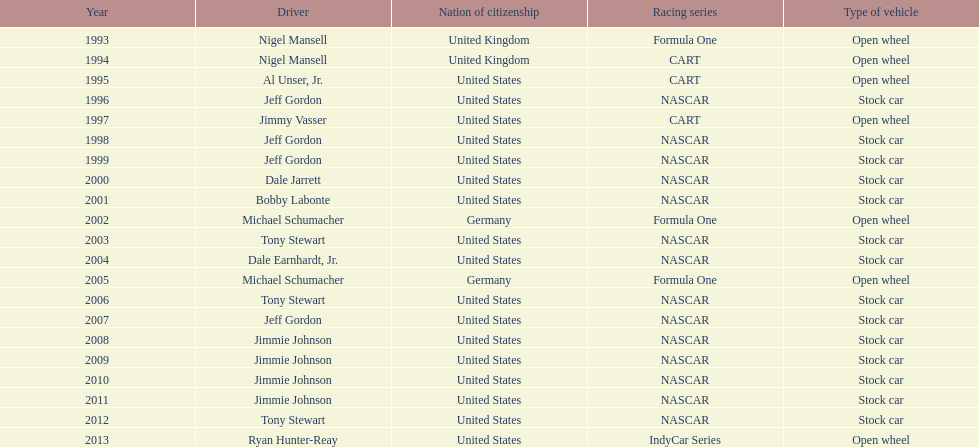Which drivers have won the best driver espy award? Nigel Mansell, Nigel Mansell, Al Unser, Jr., Jeff Gordon, Jimmy Vasser, Jeff Gordon, Jeff Gordon, Dale Jarrett, Bobby Labonte, Michael Schumacher, Tony Stewart, Dale Earnhardt, Jr., Michael Schumacher, Tony Stewart, Jeff Gordon, Jimmie Johnson, Jimmie Johnson, Jimmie Johnson, Jimmie Johnson, Tony Stewart, Ryan Hunter-Reay. Of these, which only appear once? Al Unser, Jr., Jimmy Vasser, Dale Jarrett, Dale Earnhardt, Jr., Ryan Hunter-Reay. Which of these are from the cart racing series? Al Unser, Jr., Jimmy Vasser. Of these, which received their award first? Al Unser, Jr. 